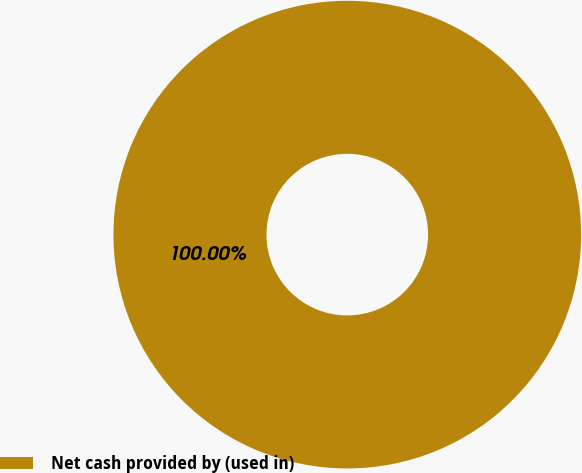<chart> <loc_0><loc_0><loc_500><loc_500><pie_chart><fcel>Net cash provided by (used in)<nl><fcel>100.0%<nl></chart> 